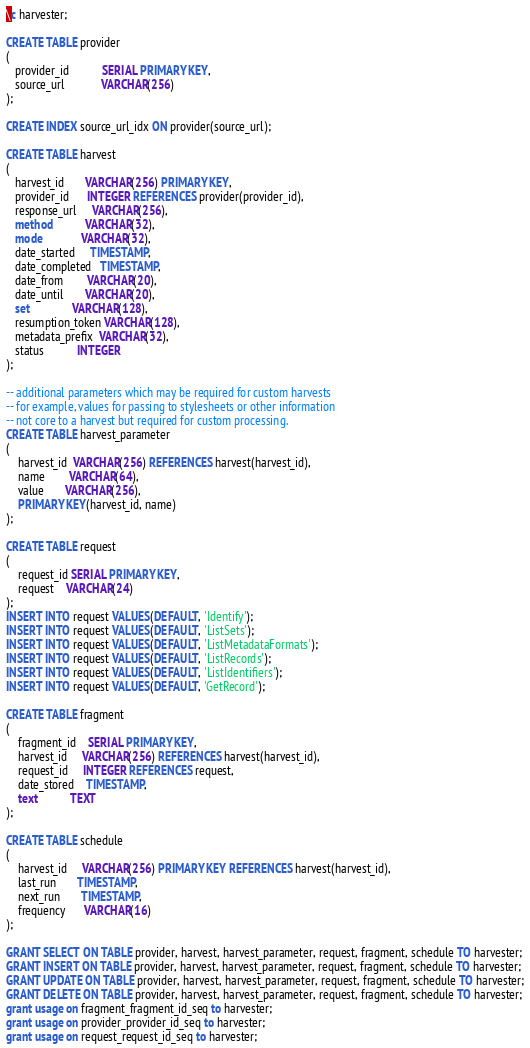<code> <loc_0><loc_0><loc_500><loc_500><_SQL_>\c harvester;

CREATE TABLE provider
(
   provider_id           SERIAL PRIMARY KEY,
   source_url            VARCHAR(256)
);

CREATE INDEX source_url_idx ON provider(source_url);

CREATE TABLE harvest
(
   harvest_id       VARCHAR(256) PRIMARY KEY,
   provider_id      INTEGER REFERENCES provider(provider_id),
   response_url     VARCHAR(256),
   method           VARCHAR(32),
   mode             VARCHAR(32),
   date_started     TIMESTAMP,
   date_completed   TIMESTAMP,
   date_from        VARCHAR(20),
   date_until       VARCHAR(20),
   set              VARCHAR(128),
   resumption_token VARCHAR(128),
   metadata_prefix  VARCHAR(32),
   status           INTEGER
);

-- additional parameters which may be required for custom harvests 
-- for example, values for passing to stylesheets or other information
-- not core to a harvest but required for custom processing.
CREATE TABLE harvest_parameter
(
    harvest_id  VARCHAR(256) REFERENCES harvest(harvest_id),
    name        VARCHAR(64),
    value       VARCHAR(256),
    PRIMARY KEY(harvest_id, name)    
);

CREATE TABLE request
(
    request_id SERIAL PRIMARY KEY,
    request    VARCHAR(24)
);
INSERT INTO request VALUES(DEFAULT, 'Identify');
INSERT INTO request VALUES(DEFAULT, 'ListSets');
INSERT INTO request VALUES(DEFAULT, 'ListMetadataFormats');
INSERT INTO request VALUES(DEFAULT, 'ListRecords');
INSERT INTO request VALUES(DEFAULT, 'ListIdentifiers');
INSERT INTO request VALUES(DEFAULT, 'GetRecord');

CREATE TABLE fragment
(
    fragment_id    SERIAL PRIMARY KEY,
    harvest_id     VARCHAR(256) REFERENCES harvest(harvest_id),
    request_id     INTEGER REFERENCES request,
    date_stored    TIMESTAMP,
    text           TEXT
);

CREATE TABLE schedule
(
    harvest_id     VARCHAR(256) PRIMARY KEY REFERENCES harvest(harvest_id),
    last_run       TIMESTAMP,
    next_run       TIMESTAMP,
    frequency      VARCHAR(16)
);

GRANT SELECT ON TABLE provider, harvest, harvest_parameter, request, fragment, schedule TO harvester;
GRANT INSERT ON TABLE provider, harvest, harvest_parameter, request, fragment, schedule TO harvester;
GRANT UPDATE ON TABLE provider, harvest, harvest_parameter, request, fragment, schedule TO harvester;
GRANT DELETE ON TABLE provider, harvest, harvest_parameter, request, fragment, schedule TO harvester;
grant usage on fragment_fragment_id_seq to harvester;
grant usage on provider_provider_id_seq to harvester;
grant usage on request_request_id_seq to harvester;</code> 